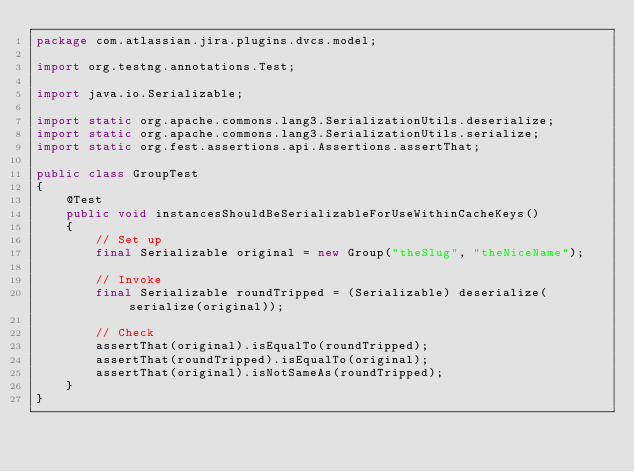<code> <loc_0><loc_0><loc_500><loc_500><_Java_>package com.atlassian.jira.plugins.dvcs.model;

import org.testng.annotations.Test;

import java.io.Serializable;

import static org.apache.commons.lang3.SerializationUtils.deserialize;
import static org.apache.commons.lang3.SerializationUtils.serialize;
import static org.fest.assertions.api.Assertions.assertThat;

public class GroupTest
{
    @Test
    public void instancesShouldBeSerializableForUseWithinCacheKeys()
    {
        // Set up
        final Serializable original = new Group("theSlug", "theNiceName");

        // Invoke
        final Serializable roundTripped = (Serializable) deserialize(serialize(original));

        // Check
        assertThat(original).isEqualTo(roundTripped);
        assertThat(roundTripped).isEqualTo(original);
        assertThat(original).isNotSameAs(roundTripped);
    }
}
</code> 